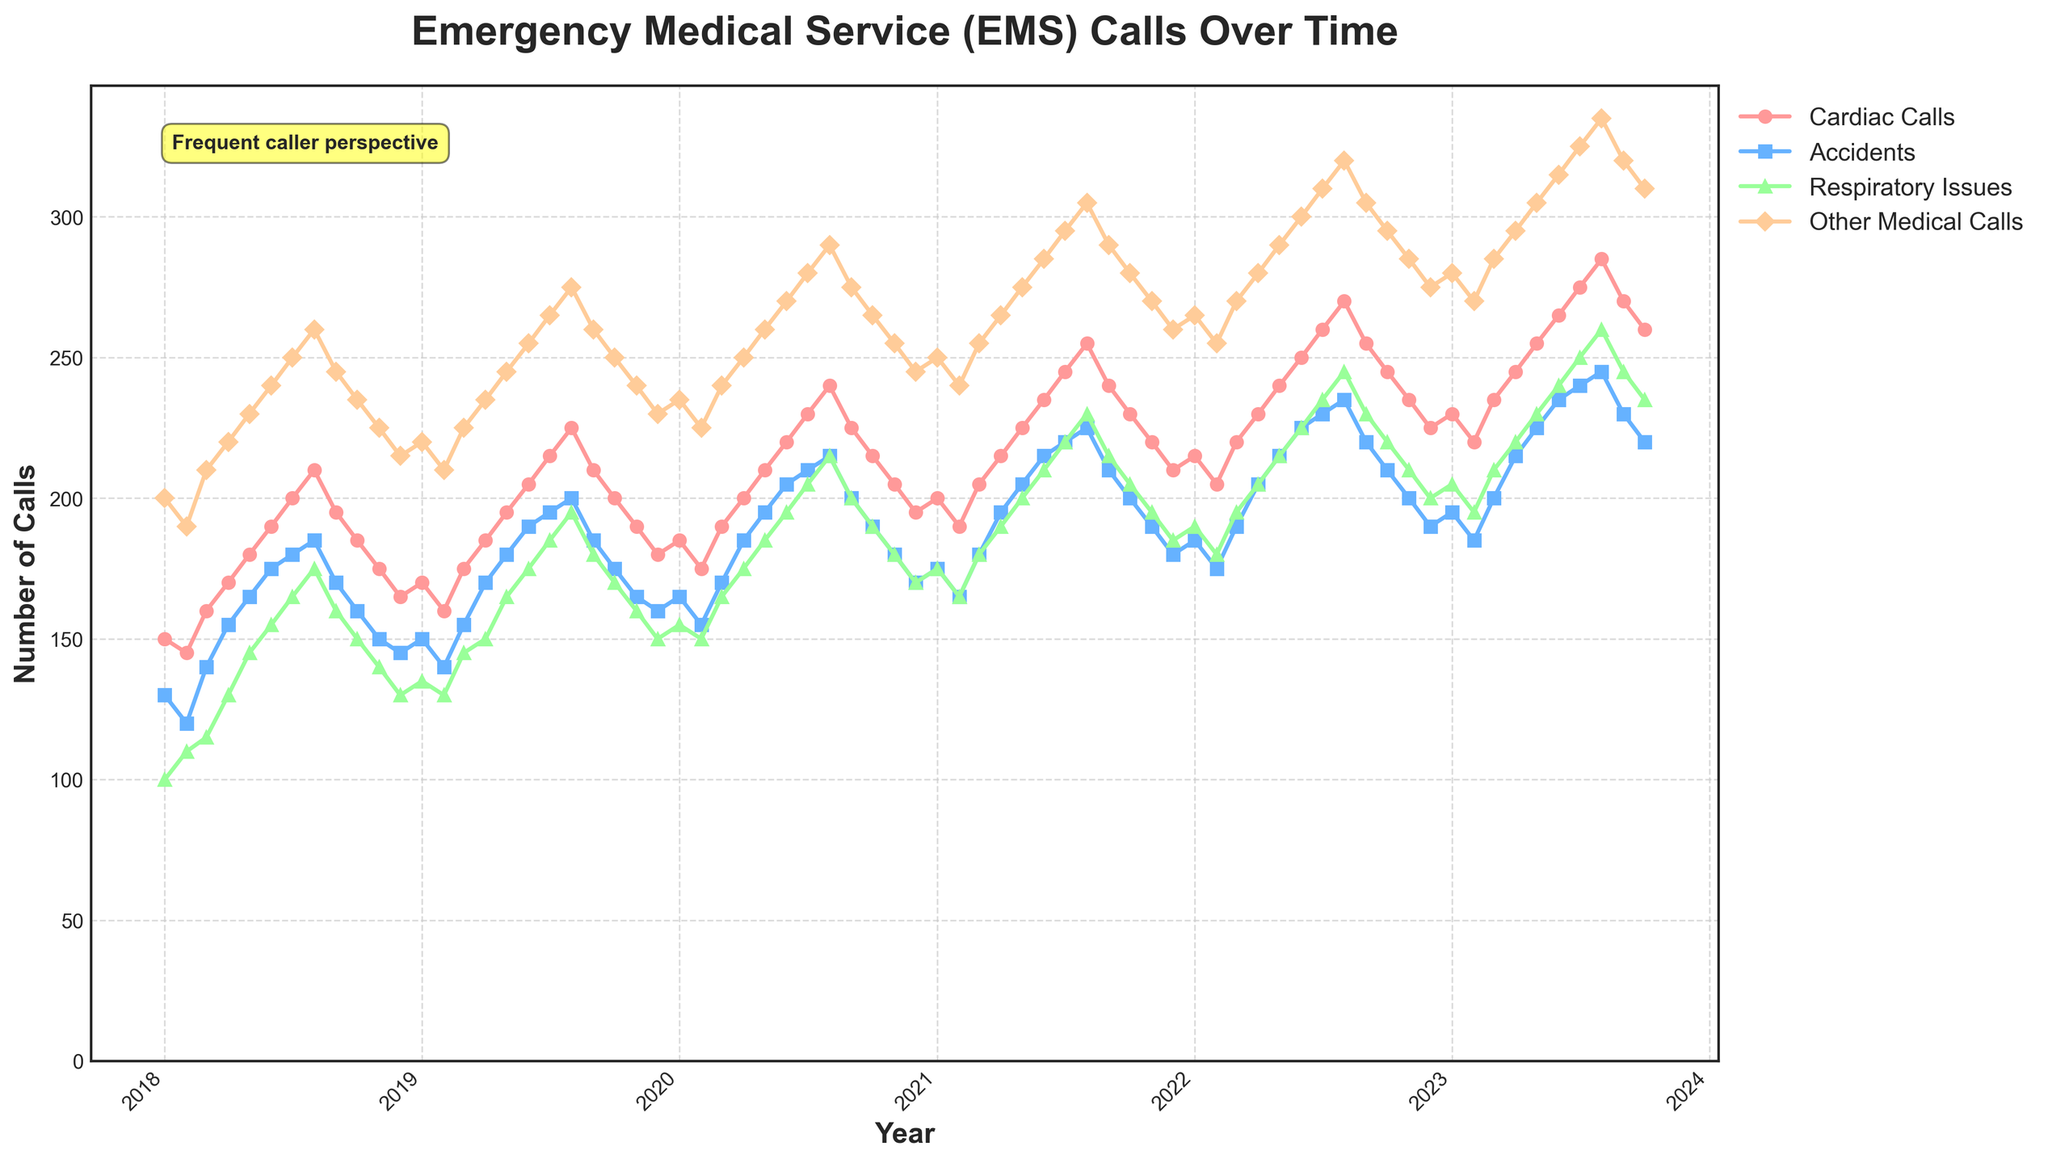What's the title of the plot? The title of the plot is displayed prominently at the top and reads "Emergency Medical Service (EMS) Calls Over Time".
Answer: Emergency Medical Service (EMS) Calls Over Time How many call types are depicted in the plot, and what are they? The plot contains four distinct call types, which are indicated by the legend: "Cardiac Calls", "Accidents", "Respiratory Issues", and "Other Medical Calls".
Answer: Four: Cardiac Calls, Accidents, Respiratory Issues, Other Medical Calls What is the overall trend in Cardiac Calls over the 5-year period? By observing the data points connected by lines for "Cardiac Calls", it's evident that the number of calls has shown a gradual and consistent increase over the 5-year period from around 150 to 285 calls per month.
Answer: An increasing trend Which month and year had the highest number of Respiratory Issues calls? By following the line for "Respiratory Issues" and identifying the peak point, it's clear that August 2023 had the highest number of calls with 260.
Answer: August 2023 During which year did the 'Accidents' call type experience a significant increase, and by how much did it increase from the start to the end of that year? In 2020, the 'Accidents' call type experienced a significant increase. At the start of 2020 (January), there were 165 calls, and by the end (December), there were 170 calls, marking a 30-call increase.
Answer: 2020; increased by 30 calls Compare the number of 'Other Medical Calls' in January of 2018 and January of 2023. Which year had more calls? Observing the data points for 'Other Medical Calls' in January 2018 and January 2023, January 2018 had 200 calls and January 2023 had 280 calls, indicating January 2023 had more calls.
Answer: January 2023 What is the approximate average number of 'Accidents' calls from January 2022 to October 2022? Taking the monthly data points for 'Accidents' from January to October 2022 (185, 175, 190, 205, 215, 225, 230, 235, 220, 210), summing them gives 2090. There are 10 months, so the average is 2090/10 = 209.
Answer: 209 Between which consecutive years did 'Cardiac Calls' see the largest increase, and what was the amount of increase? Observing the year-end data points for 'Cardiac Calls', from December 2019 to December 2020, the calls increased from 180 to 195, showing an increase of 15 calls. No other consecutive years show a greater jump.
Answer: 2019-2020; 15 calls What is the difference in the number of 'Other Medical Calls' between the month with the highest calls and the month with the lowest calls? The month with the highest 'Other Medical Calls' is August 2023 with 335 calls, and the lowest is February 2018 with 190 calls. The difference is 335 - 190 = 145.
Answer: 145 Is there any period where the number of 'Cardiac Calls' remained fairly stable? If yes, identify the period. Examining the line for 'Cardiac Calls', there is a relatively stable period from October 2018 to February 2019, with calls ranging from 165 to 170.
Answer: October 2018 to February 2019 